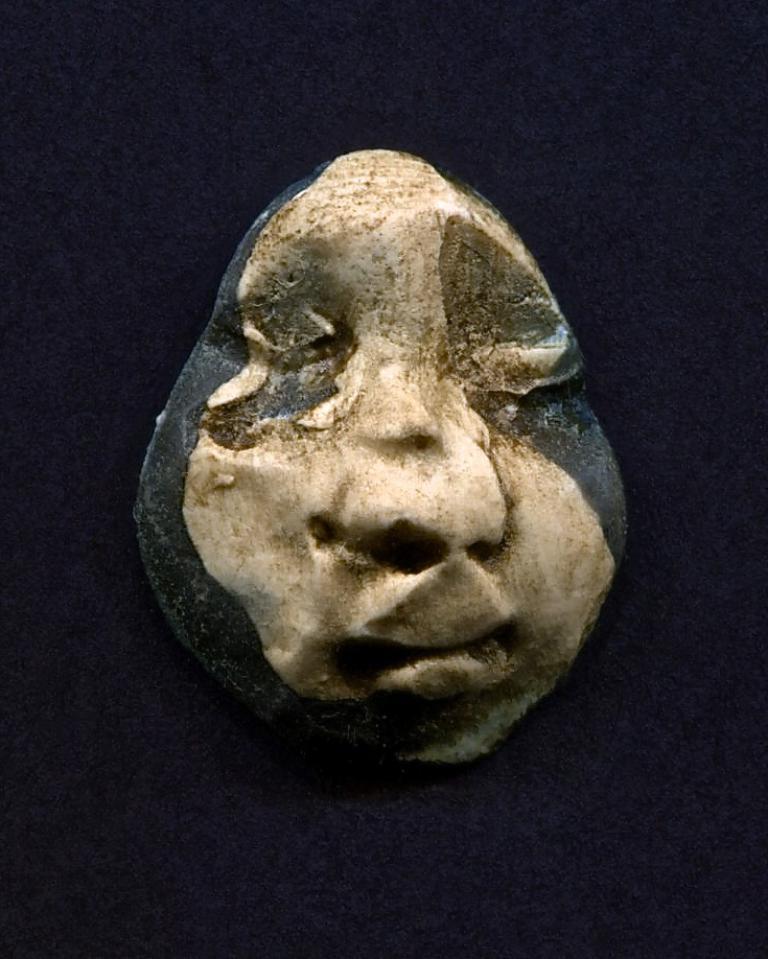Can you describe this image briefly? In the middle of the image there is a sculpture. In this image the background is dark. 